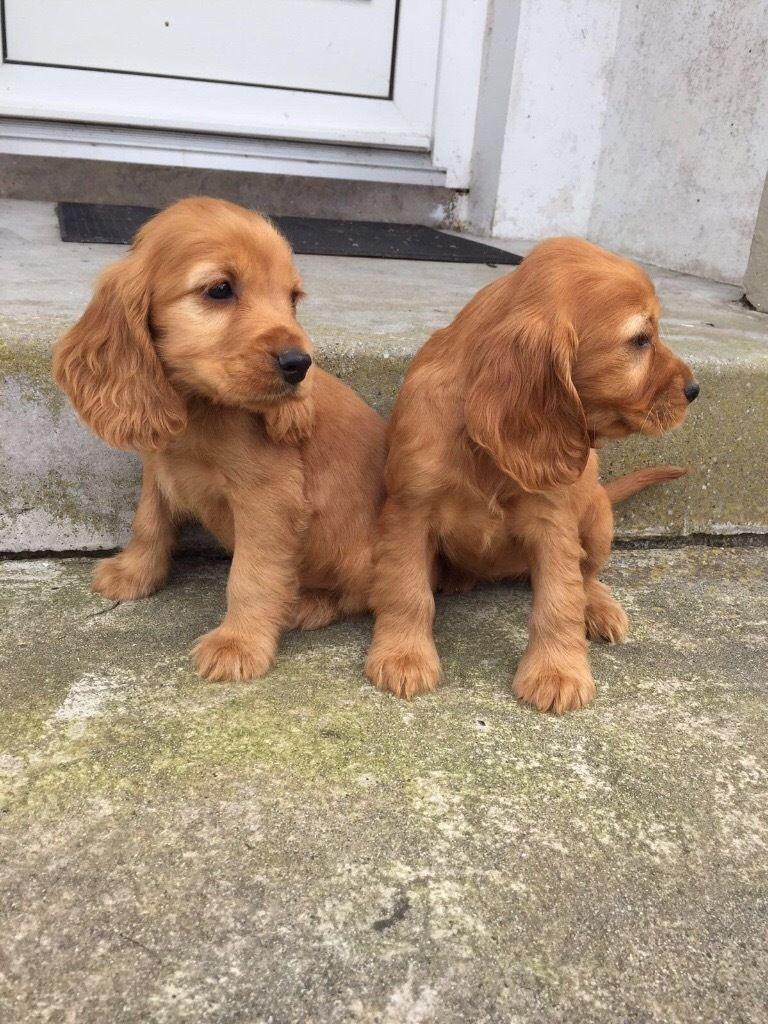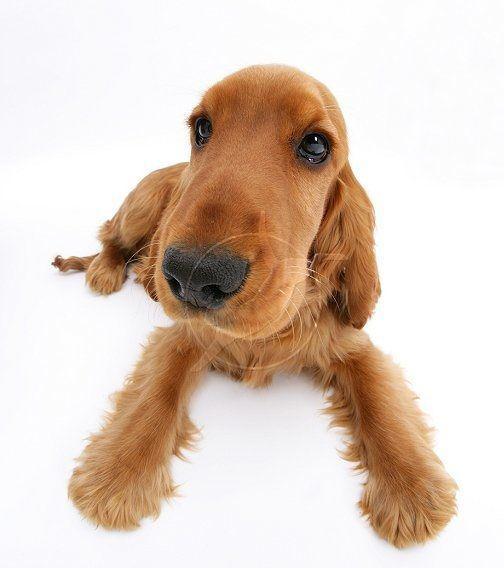The first image is the image on the left, the second image is the image on the right. For the images shown, is this caption "A blue object hangs from the collar of the dog in one of the images." true? Answer yes or no. No. 